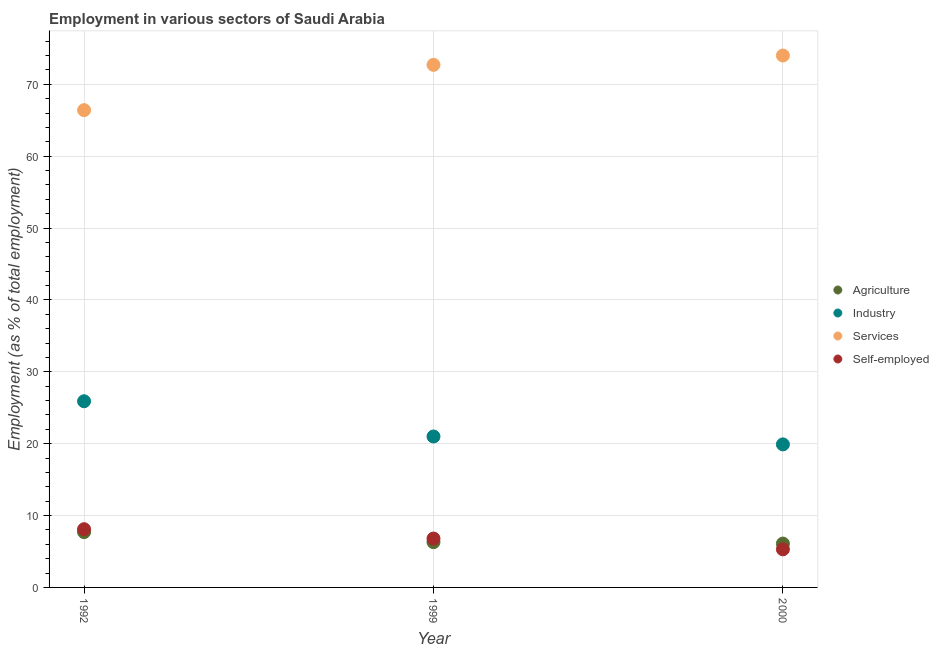How many different coloured dotlines are there?
Make the answer very short. 4. What is the percentage of self employed workers in 2000?
Your answer should be compact. 5.3. Across all years, what is the maximum percentage of self employed workers?
Make the answer very short. 8.1. Across all years, what is the minimum percentage of workers in agriculture?
Give a very brief answer. 6.1. What is the total percentage of workers in industry in the graph?
Ensure brevity in your answer.  66.8. What is the difference between the percentage of workers in agriculture in 1992 and that in 2000?
Give a very brief answer. 1.6. What is the difference between the percentage of self employed workers in 2000 and the percentage of workers in industry in 1992?
Provide a short and direct response. -20.6. What is the average percentage of workers in agriculture per year?
Provide a succinct answer. 6.7. In the year 1999, what is the difference between the percentage of self employed workers and percentage of workers in services?
Ensure brevity in your answer.  -65.9. What is the ratio of the percentage of workers in services in 1992 to that in 1999?
Your answer should be compact. 0.91. What is the difference between the highest and the second highest percentage of self employed workers?
Offer a very short reply. 1.3. What is the difference between the highest and the lowest percentage of workers in industry?
Ensure brevity in your answer.  6. Is the percentage of workers in services strictly less than the percentage of workers in agriculture over the years?
Provide a short and direct response. No. How many dotlines are there?
Provide a succinct answer. 4. What is the difference between two consecutive major ticks on the Y-axis?
Make the answer very short. 10. Does the graph contain any zero values?
Make the answer very short. No. Does the graph contain grids?
Your response must be concise. Yes. What is the title of the graph?
Your answer should be very brief. Employment in various sectors of Saudi Arabia. What is the label or title of the X-axis?
Provide a short and direct response. Year. What is the label or title of the Y-axis?
Keep it short and to the point. Employment (as % of total employment). What is the Employment (as % of total employment) of Agriculture in 1992?
Give a very brief answer. 7.7. What is the Employment (as % of total employment) in Industry in 1992?
Make the answer very short. 25.9. What is the Employment (as % of total employment) in Services in 1992?
Offer a terse response. 66.4. What is the Employment (as % of total employment) of Self-employed in 1992?
Your answer should be very brief. 8.1. What is the Employment (as % of total employment) of Agriculture in 1999?
Ensure brevity in your answer.  6.3. What is the Employment (as % of total employment) in Services in 1999?
Ensure brevity in your answer.  72.7. What is the Employment (as % of total employment) in Self-employed in 1999?
Give a very brief answer. 6.8. What is the Employment (as % of total employment) of Agriculture in 2000?
Provide a short and direct response. 6.1. What is the Employment (as % of total employment) of Industry in 2000?
Your response must be concise. 19.9. What is the Employment (as % of total employment) in Self-employed in 2000?
Provide a succinct answer. 5.3. Across all years, what is the maximum Employment (as % of total employment) of Agriculture?
Your response must be concise. 7.7. Across all years, what is the maximum Employment (as % of total employment) in Industry?
Give a very brief answer. 25.9. Across all years, what is the maximum Employment (as % of total employment) of Self-employed?
Your answer should be very brief. 8.1. Across all years, what is the minimum Employment (as % of total employment) of Agriculture?
Provide a short and direct response. 6.1. Across all years, what is the minimum Employment (as % of total employment) of Industry?
Give a very brief answer. 19.9. Across all years, what is the minimum Employment (as % of total employment) in Services?
Give a very brief answer. 66.4. Across all years, what is the minimum Employment (as % of total employment) of Self-employed?
Make the answer very short. 5.3. What is the total Employment (as % of total employment) in Agriculture in the graph?
Ensure brevity in your answer.  20.1. What is the total Employment (as % of total employment) in Industry in the graph?
Your answer should be very brief. 66.8. What is the total Employment (as % of total employment) in Services in the graph?
Make the answer very short. 213.1. What is the total Employment (as % of total employment) in Self-employed in the graph?
Provide a succinct answer. 20.2. What is the difference between the Employment (as % of total employment) in Agriculture in 1992 and that in 1999?
Your response must be concise. 1.4. What is the difference between the Employment (as % of total employment) in Industry in 1992 and that in 2000?
Provide a succinct answer. 6. What is the difference between the Employment (as % of total employment) in Agriculture in 1999 and that in 2000?
Provide a short and direct response. 0.2. What is the difference between the Employment (as % of total employment) of Industry in 1999 and that in 2000?
Your answer should be compact. 1.1. What is the difference between the Employment (as % of total employment) of Services in 1999 and that in 2000?
Your answer should be compact. -1.3. What is the difference between the Employment (as % of total employment) of Agriculture in 1992 and the Employment (as % of total employment) of Services in 1999?
Ensure brevity in your answer.  -65. What is the difference between the Employment (as % of total employment) of Industry in 1992 and the Employment (as % of total employment) of Services in 1999?
Provide a short and direct response. -46.8. What is the difference between the Employment (as % of total employment) in Industry in 1992 and the Employment (as % of total employment) in Self-employed in 1999?
Ensure brevity in your answer.  19.1. What is the difference between the Employment (as % of total employment) of Services in 1992 and the Employment (as % of total employment) of Self-employed in 1999?
Provide a short and direct response. 59.6. What is the difference between the Employment (as % of total employment) of Agriculture in 1992 and the Employment (as % of total employment) of Industry in 2000?
Keep it short and to the point. -12.2. What is the difference between the Employment (as % of total employment) of Agriculture in 1992 and the Employment (as % of total employment) of Services in 2000?
Keep it short and to the point. -66.3. What is the difference between the Employment (as % of total employment) of Agriculture in 1992 and the Employment (as % of total employment) of Self-employed in 2000?
Your answer should be very brief. 2.4. What is the difference between the Employment (as % of total employment) of Industry in 1992 and the Employment (as % of total employment) of Services in 2000?
Give a very brief answer. -48.1. What is the difference between the Employment (as % of total employment) in Industry in 1992 and the Employment (as % of total employment) in Self-employed in 2000?
Offer a very short reply. 20.6. What is the difference between the Employment (as % of total employment) in Services in 1992 and the Employment (as % of total employment) in Self-employed in 2000?
Your answer should be very brief. 61.1. What is the difference between the Employment (as % of total employment) of Agriculture in 1999 and the Employment (as % of total employment) of Services in 2000?
Keep it short and to the point. -67.7. What is the difference between the Employment (as % of total employment) in Agriculture in 1999 and the Employment (as % of total employment) in Self-employed in 2000?
Your answer should be compact. 1. What is the difference between the Employment (as % of total employment) of Industry in 1999 and the Employment (as % of total employment) of Services in 2000?
Offer a very short reply. -53. What is the difference between the Employment (as % of total employment) of Services in 1999 and the Employment (as % of total employment) of Self-employed in 2000?
Your answer should be compact. 67.4. What is the average Employment (as % of total employment) of Agriculture per year?
Provide a short and direct response. 6.7. What is the average Employment (as % of total employment) in Industry per year?
Offer a very short reply. 22.27. What is the average Employment (as % of total employment) of Services per year?
Your answer should be very brief. 71.03. What is the average Employment (as % of total employment) of Self-employed per year?
Your answer should be compact. 6.73. In the year 1992, what is the difference between the Employment (as % of total employment) of Agriculture and Employment (as % of total employment) of Industry?
Your answer should be compact. -18.2. In the year 1992, what is the difference between the Employment (as % of total employment) in Agriculture and Employment (as % of total employment) in Services?
Ensure brevity in your answer.  -58.7. In the year 1992, what is the difference between the Employment (as % of total employment) in Agriculture and Employment (as % of total employment) in Self-employed?
Make the answer very short. -0.4. In the year 1992, what is the difference between the Employment (as % of total employment) in Industry and Employment (as % of total employment) in Services?
Your answer should be very brief. -40.5. In the year 1992, what is the difference between the Employment (as % of total employment) of Services and Employment (as % of total employment) of Self-employed?
Offer a terse response. 58.3. In the year 1999, what is the difference between the Employment (as % of total employment) in Agriculture and Employment (as % of total employment) in Industry?
Make the answer very short. -14.7. In the year 1999, what is the difference between the Employment (as % of total employment) in Agriculture and Employment (as % of total employment) in Services?
Make the answer very short. -66.4. In the year 1999, what is the difference between the Employment (as % of total employment) in Industry and Employment (as % of total employment) in Services?
Keep it short and to the point. -51.7. In the year 1999, what is the difference between the Employment (as % of total employment) in Industry and Employment (as % of total employment) in Self-employed?
Your answer should be compact. 14.2. In the year 1999, what is the difference between the Employment (as % of total employment) in Services and Employment (as % of total employment) in Self-employed?
Make the answer very short. 65.9. In the year 2000, what is the difference between the Employment (as % of total employment) of Agriculture and Employment (as % of total employment) of Industry?
Give a very brief answer. -13.8. In the year 2000, what is the difference between the Employment (as % of total employment) of Agriculture and Employment (as % of total employment) of Services?
Provide a succinct answer. -67.9. In the year 2000, what is the difference between the Employment (as % of total employment) in Industry and Employment (as % of total employment) in Services?
Offer a terse response. -54.1. In the year 2000, what is the difference between the Employment (as % of total employment) in Services and Employment (as % of total employment) in Self-employed?
Offer a terse response. 68.7. What is the ratio of the Employment (as % of total employment) of Agriculture in 1992 to that in 1999?
Provide a succinct answer. 1.22. What is the ratio of the Employment (as % of total employment) in Industry in 1992 to that in 1999?
Make the answer very short. 1.23. What is the ratio of the Employment (as % of total employment) of Services in 1992 to that in 1999?
Provide a short and direct response. 0.91. What is the ratio of the Employment (as % of total employment) of Self-employed in 1992 to that in 1999?
Make the answer very short. 1.19. What is the ratio of the Employment (as % of total employment) of Agriculture in 1992 to that in 2000?
Provide a succinct answer. 1.26. What is the ratio of the Employment (as % of total employment) of Industry in 1992 to that in 2000?
Ensure brevity in your answer.  1.3. What is the ratio of the Employment (as % of total employment) of Services in 1992 to that in 2000?
Offer a terse response. 0.9. What is the ratio of the Employment (as % of total employment) of Self-employed in 1992 to that in 2000?
Give a very brief answer. 1.53. What is the ratio of the Employment (as % of total employment) of Agriculture in 1999 to that in 2000?
Keep it short and to the point. 1.03. What is the ratio of the Employment (as % of total employment) in Industry in 1999 to that in 2000?
Your answer should be very brief. 1.06. What is the ratio of the Employment (as % of total employment) in Services in 1999 to that in 2000?
Ensure brevity in your answer.  0.98. What is the ratio of the Employment (as % of total employment) of Self-employed in 1999 to that in 2000?
Provide a succinct answer. 1.28. What is the difference between the highest and the second highest Employment (as % of total employment) in Agriculture?
Your answer should be compact. 1.4. What is the difference between the highest and the second highest Employment (as % of total employment) of Industry?
Offer a very short reply. 4.9. What is the difference between the highest and the second highest Employment (as % of total employment) of Services?
Your answer should be very brief. 1.3. What is the difference between the highest and the lowest Employment (as % of total employment) of Industry?
Keep it short and to the point. 6. What is the difference between the highest and the lowest Employment (as % of total employment) of Services?
Make the answer very short. 7.6. 